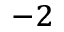<formula> <loc_0><loc_0><loc_500><loc_500>^ { - 2 }</formula> 